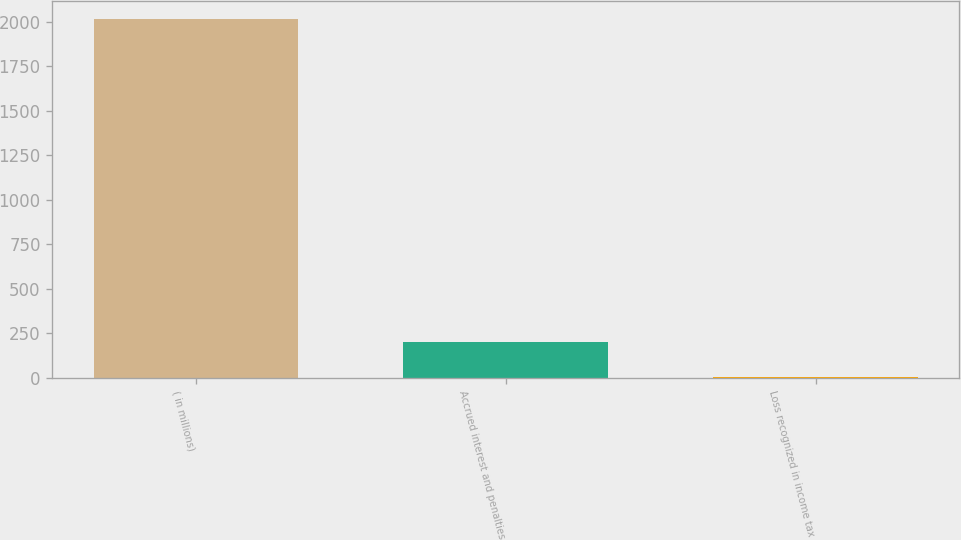<chart> <loc_0><loc_0><loc_500><loc_500><bar_chart><fcel>( in millions)<fcel>Accrued interest and penalties<fcel>Loss recognized in income tax<nl><fcel>2018<fcel>203.6<fcel>2<nl></chart> 